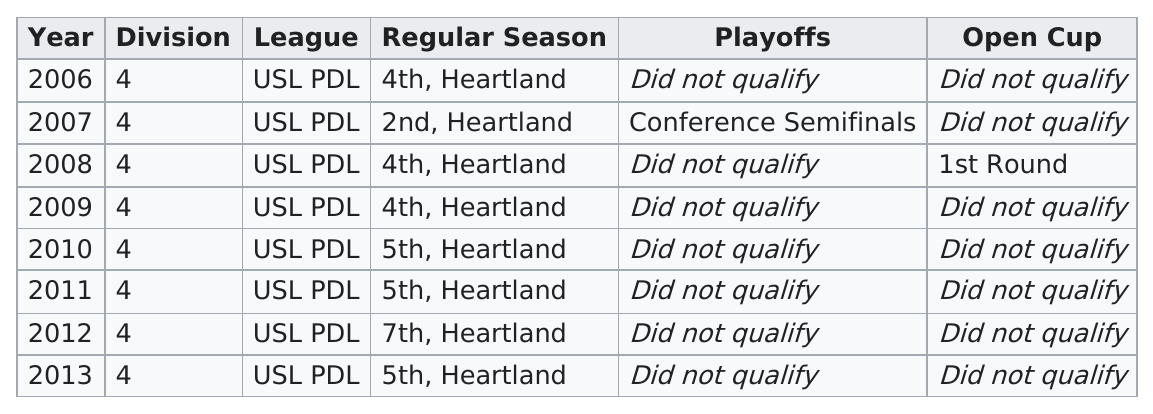Give some essential details in this illustration. The team finished the regular season in at least 4th place for 4 years. For how many consecutive years was the result 4th place? 2... The team qualified for the playoffs for the first time in 2007. The team finished the regular season in fourth place three times. In 2007, the year was more successful than 2012. 